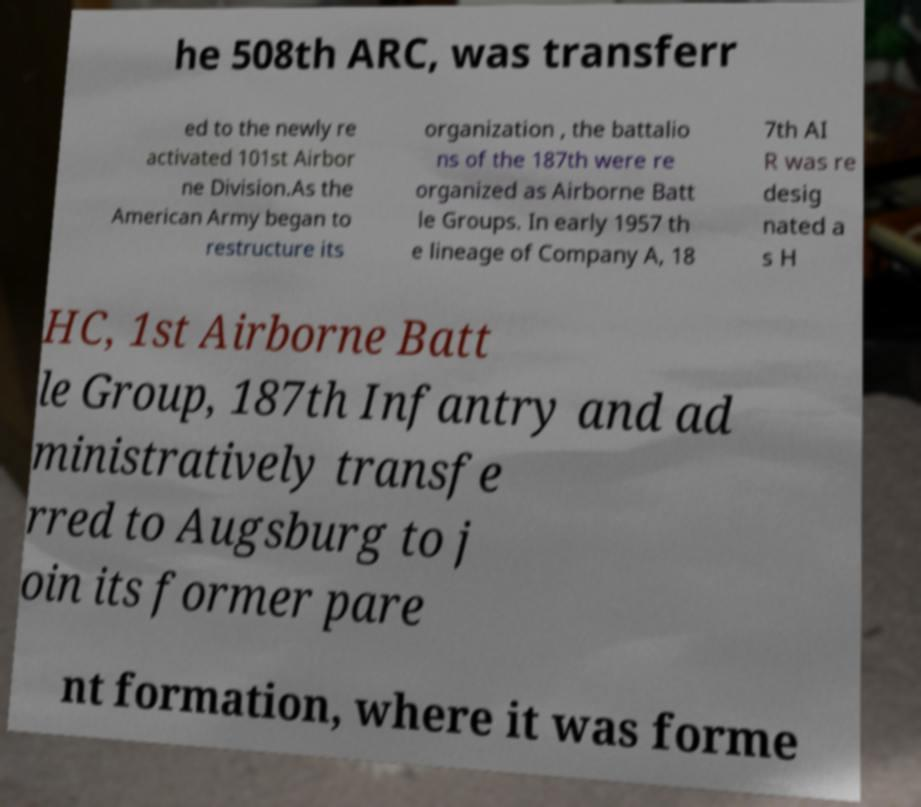I need the written content from this picture converted into text. Can you do that? he 508th ARC, was transferr ed to the newly re activated 101st Airbor ne Division.As the American Army began to restructure its organization , the battalio ns of the 187th were re organized as Airborne Batt le Groups. In early 1957 th e lineage of Company A, 18 7th AI R was re desig nated a s H HC, 1st Airborne Batt le Group, 187th Infantry and ad ministratively transfe rred to Augsburg to j oin its former pare nt formation, where it was forme 